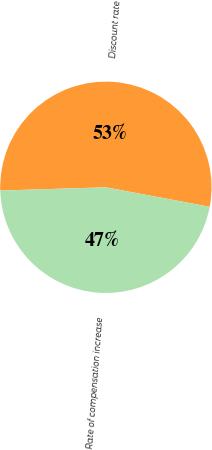<chart> <loc_0><loc_0><loc_500><loc_500><pie_chart><fcel>Discount rate<fcel>Rate of compensation increase<nl><fcel>53.44%<fcel>46.56%<nl></chart> 